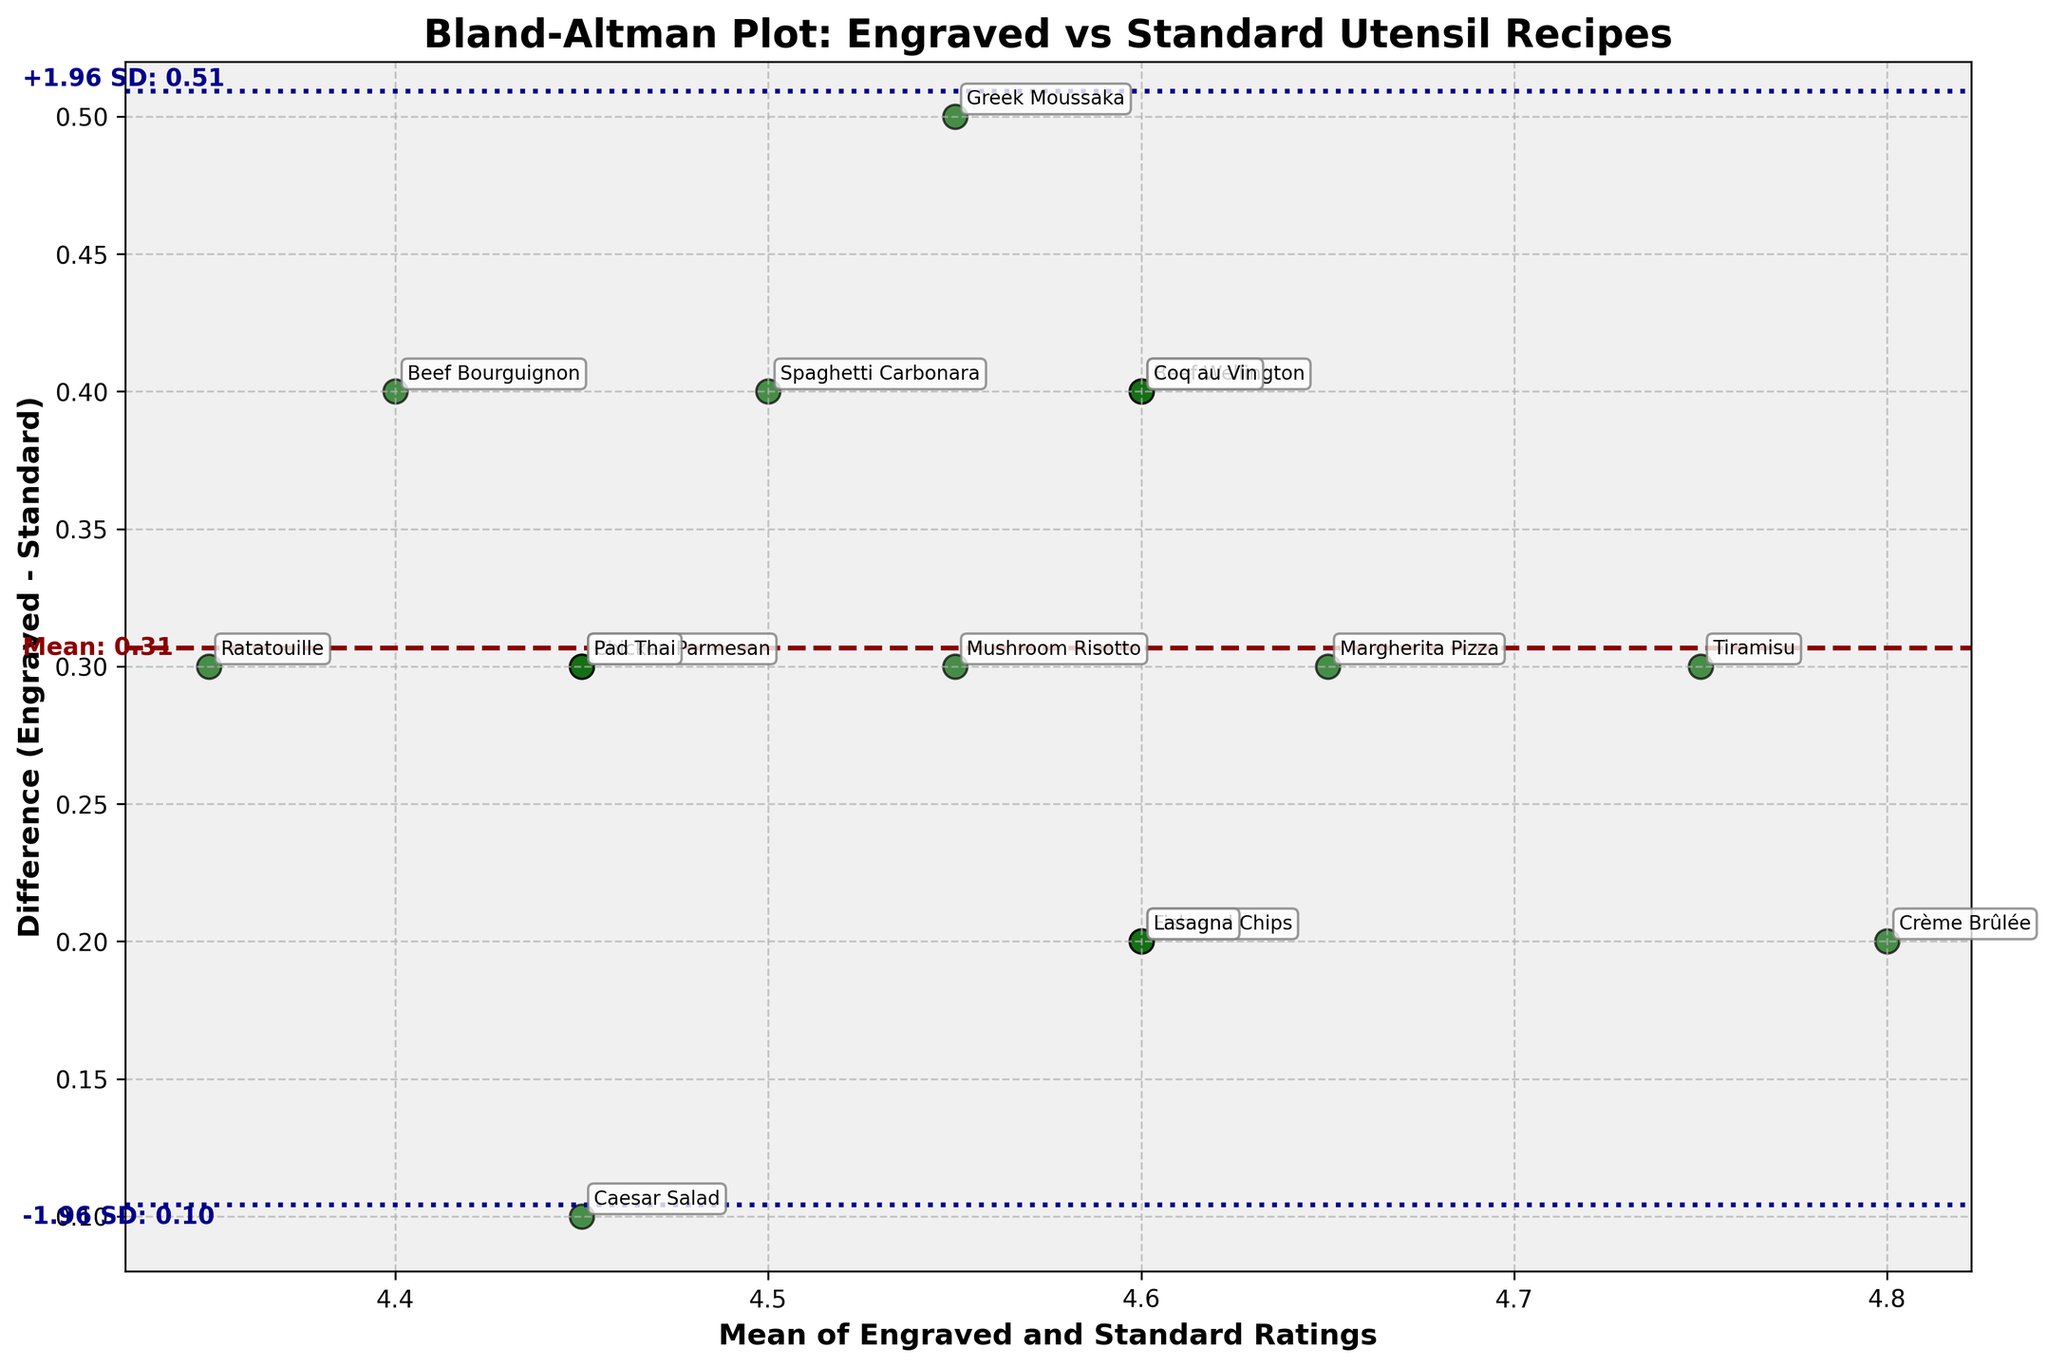What is the title of the Bland–Altman plot? The title is usually at the top of the figure. For this plot, it is clearly displayed there.
Answer: Bland-Altman Plot: Engraved vs Standard Utensil Recipes How many data points are on the plot? Each data point corresponds to one dish. By counting the annotated names, you can determine the number.
Answer: 15 What are the labels of the x-axis and y-axis? The x-axis and y-axis labels are usually marked alongside each axis to explain what they represent.
Answer: Mean of Engraved and Standard Ratings (x-axis), Difference (Engraved - Standard) (y-axis) Which dish has the highest mean rating? The mean rating is found along the x-axis. Locate the furthest right annotated point.
Answer: Crème Brûlée What is the mean difference between the engraved and standard ratings? The mean difference is marked by the dashed horizontal line in the plot and is also annotated alongside this line.
Answer: 0.39 What is the dish name with the highest negative difference? The dish with the highest negative difference will be the lowest point on the y-axis. Check its label.
Answer: Beef Bourguignon Are there any dishes that lie exactly on the mean difference line? To check if a dish lies on the mean difference line, verify if any scatter point aligns horizontally with the dashed line.
Answer: Yes, Chicken Parmesan and Pad Thai What are the values for the limits of agreement? The limits of agreement are indicated by dotted lines above and below the mean difference line and annotated with their values.
Answer: +1.96 SD: 0.88, -1.96 SD: -0.10 Compare the ratings for "Beef Wellington" and "Ratatouille." Which has a greater difference in ratings? Locate both dishes on the plot and compare their y-axis values to see which has a larger absolute difference.
Answer: Beef Wellington What is the standard deviation of the differences? The standard deviation can be inferred from the limits of agreement. Since they are mean difference ± 1.96 * SD, calculate it from the annotated values.
Answer: About 0.25 